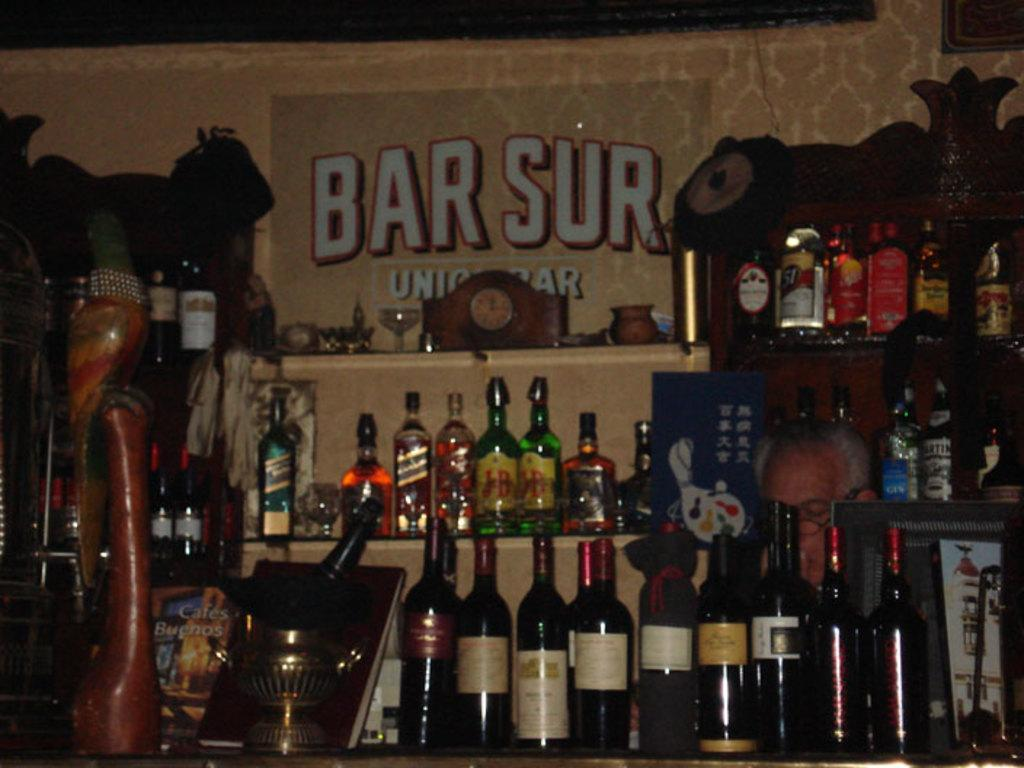<image>
Render a clear and concise summary of the photo. Bottles of wine line up in front of a wall with Bar Sur on it. 